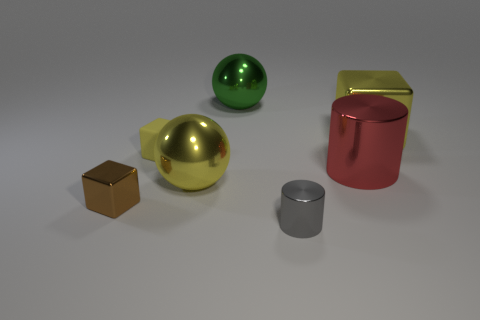Subtract all brown balls. How many yellow blocks are left? 2 Subtract all yellow cubes. How many cubes are left? 1 Add 1 gray metal objects. How many objects exist? 8 Subtract all spheres. How many objects are left? 5 Subtract 2 yellow blocks. How many objects are left? 5 Subtract all tiny gray matte cylinders. Subtract all red shiny cylinders. How many objects are left? 6 Add 4 big red metallic objects. How many big red metallic objects are left? 5 Add 2 big red objects. How many big red objects exist? 3 